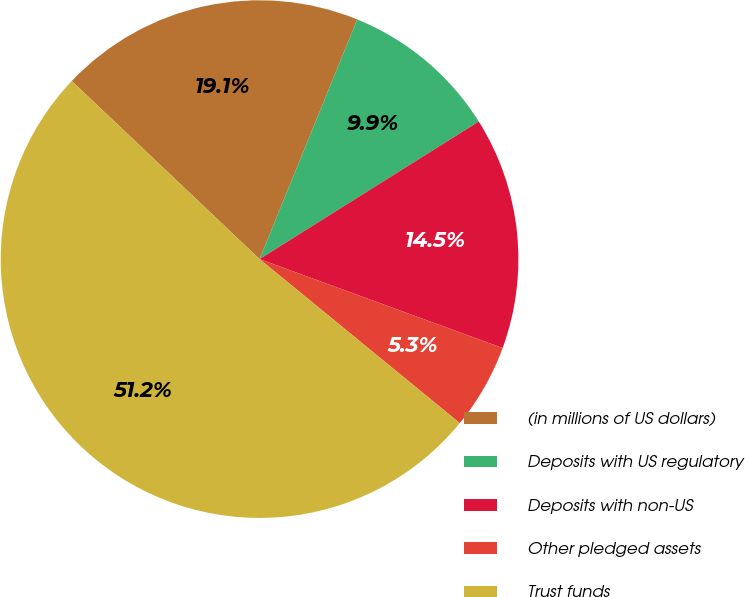Convert chart. <chart><loc_0><loc_0><loc_500><loc_500><pie_chart><fcel>(in millions of US dollars)<fcel>Deposits with US regulatory<fcel>Deposits with non-US<fcel>Other pledged assets<fcel>Trust funds<nl><fcel>19.08%<fcel>9.92%<fcel>14.5%<fcel>5.34%<fcel>51.15%<nl></chart> 